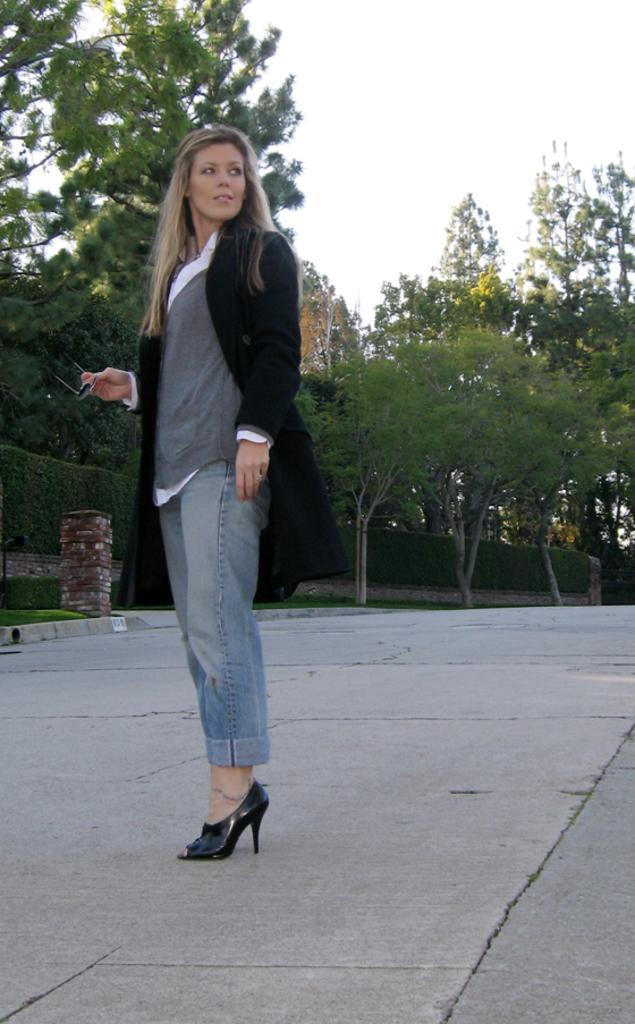Describe this image in one or two sentences. In this image we can see a lady standing on the floor and holding spectacles in her hand. In the background we can see bushes, trees and sky. 